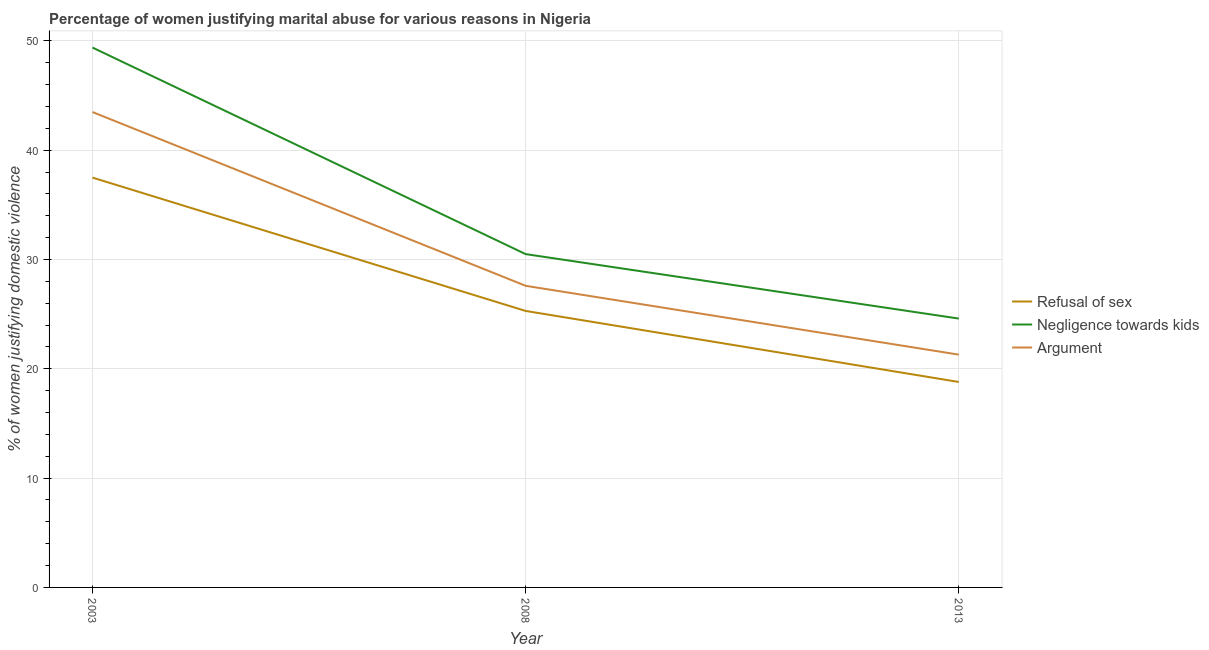Does the line corresponding to percentage of women justifying domestic violence due to negligence towards kids intersect with the line corresponding to percentage of women justifying domestic violence due to refusal of sex?
Your response must be concise. No. What is the percentage of women justifying domestic violence due to negligence towards kids in 2008?
Offer a terse response. 30.5. Across all years, what is the maximum percentage of women justifying domestic violence due to negligence towards kids?
Your answer should be compact. 49.4. Across all years, what is the minimum percentage of women justifying domestic violence due to refusal of sex?
Your response must be concise. 18.8. What is the total percentage of women justifying domestic violence due to negligence towards kids in the graph?
Make the answer very short. 104.5. What is the difference between the percentage of women justifying domestic violence due to arguments in 2013 and the percentage of women justifying domestic violence due to refusal of sex in 2003?
Offer a terse response. -16.2. What is the average percentage of women justifying domestic violence due to arguments per year?
Your response must be concise. 30.8. In the year 2003, what is the difference between the percentage of women justifying domestic violence due to negligence towards kids and percentage of women justifying domestic violence due to refusal of sex?
Your answer should be very brief. 11.9. In how many years, is the percentage of women justifying domestic violence due to arguments greater than 4 %?
Offer a terse response. 3. What is the ratio of the percentage of women justifying domestic violence due to negligence towards kids in 2003 to that in 2008?
Provide a short and direct response. 1.62. Is the difference between the percentage of women justifying domestic violence due to negligence towards kids in 2003 and 2013 greater than the difference between the percentage of women justifying domestic violence due to refusal of sex in 2003 and 2013?
Make the answer very short. Yes. What is the difference between the highest and the lowest percentage of women justifying domestic violence due to negligence towards kids?
Your response must be concise. 24.8. In how many years, is the percentage of women justifying domestic violence due to negligence towards kids greater than the average percentage of women justifying domestic violence due to negligence towards kids taken over all years?
Offer a very short reply. 1. Is the sum of the percentage of women justifying domestic violence due to negligence towards kids in 2003 and 2013 greater than the maximum percentage of women justifying domestic violence due to refusal of sex across all years?
Your answer should be very brief. Yes. Does the percentage of women justifying domestic violence due to refusal of sex monotonically increase over the years?
Ensure brevity in your answer.  No. Is the percentage of women justifying domestic violence due to arguments strictly less than the percentage of women justifying domestic violence due to refusal of sex over the years?
Provide a succinct answer. No. How many lines are there?
Provide a short and direct response. 3. How many years are there in the graph?
Keep it short and to the point. 3. What is the difference between two consecutive major ticks on the Y-axis?
Provide a succinct answer. 10. Does the graph contain grids?
Provide a short and direct response. Yes. How many legend labels are there?
Offer a very short reply. 3. What is the title of the graph?
Offer a terse response. Percentage of women justifying marital abuse for various reasons in Nigeria. Does "Slovak Republic" appear as one of the legend labels in the graph?
Give a very brief answer. No. What is the label or title of the Y-axis?
Give a very brief answer. % of women justifying domestic violence. What is the % of women justifying domestic violence of Refusal of sex in 2003?
Offer a terse response. 37.5. What is the % of women justifying domestic violence in Negligence towards kids in 2003?
Keep it short and to the point. 49.4. What is the % of women justifying domestic violence in Argument in 2003?
Ensure brevity in your answer.  43.5. What is the % of women justifying domestic violence of Refusal of sex in 2008?
Make the answer very short. 25.3. What is the % of women justifying domestic violence in Negligence towards kids in 2008?
Make the answer very short. 30.5. What is the % of women justifying domestic violence in Argument in 2008?
Your answer should be very brief. 27.6. What is the % of women justifying domestic violence in Refusal of sex in 2013?
Make the answer very short. 18.8. What is the % of women justifying domestic violence in Negligence towards kids in 2013?
Provide a succinct answer. 24.6. What is the % of women justifying domestic violence in Argument in 2013?
Make the answer very short. 21.3. Across all years, what is the maximum % of women justifying domestic violence of Refusal of sex?
Provide a short and direct response. 37.5. Across all years, what is the maximum % of women justifying domestic violence in Negligence towards kids?
Provide a succinct answer. 49.4. Across all years, what is the maximum % of women justifying domestic violence in Argument?
Ensure brevity in your answer.  43.5. Across all years, what is the minimum % of women justifying domestic violence of Negligence towards kids?
Keep it short and to the point. 24.6. Across all years, what is the minimum % of women justifying domestic violence in Argument?
Provide a short and direct response. 21.3. What is the total % of women justifying domestic violence of Refusal of sex in the graph?
Offer a very short reply. 81.6. What is the total % of women justifying domestic violence in Negligence towards kids in the graph?
Offer a very short reply. 104.5. What is the total % of women justifying domestic violence of Argument in the graph?
Your answer should be compact. 92.4. What is the difference between the % of women justifying domestic violence of Refusal of sex in 2003 and that in 2008?
Give a very brief answer. 12.2. What is the difference between the % of women justifying domestic violence in Negligence towards kids in 2003 and that in 2008?
Give a very brief answer. 18.9. What is the difference between the % of women justifying domestic violence of Argument in 2003 and that in 2008?
Your response must be concise. 15.9. What is the difference between the % of women justifying domestic violence in Negligence towards kids in 2003 and that in 2013?
Provide a succinct answer. 24.8. What is the difference between the % of women justifying domestic violence of Argument in 2003 and that in 2013?
Offer a very short reply. 22.2. What is the difference between the % of women justifying domestic violence in Refusal of sex in 2008 and that in 2013?
Give a very brief answer. 6.5. What is the difference between the % of women justifying domestic violence of Refusal of sex in 2003 and the % of women justifying domestic violence of Negligence towards kids in 2008?
Provide a short and direct response. 7. What is the difference between the % of women justifying domestic violence of Negligence towards kids in 2003 and the % of women justifying domestic violence of Argument in 2008?
Give a very brief answer. 21.8. What is the difference between the % of women justifying domestic violence in Negligence towards kids in 2003 and the % of women justifying domestic violence in Argument in 2013?
Provide a succinct answer. 28.1. What is the difference between the % of women justifying domestic violence of Refusal of sex in 2008 and the % of women justifying domestic violence of Negligence towards kids in 2013?
Give a very brief answer. 0.7. What is the average % of women justifying domestic violence of Refusal of sex per year?
Provide a short and direct response. 27.2. What is the average % of women justifying domestic violence in Negligence towards kids per year?
Your answer should be compact. 34.83. What is the average % of women justifying domestic violence in Argument per year?
Offer a terse response. 30.8. In the year 2008, what is the difference between the % of women justifying domestic violence in Refusal of sex and % of women justifying domestic violence in Argument?
Your answer should be very brief. -2.3. In the year 2008, what is the difference between the % of women justifying domestic violence of Negligence towards kids and % of women justifying domestic violence of Argument?
Keep it short and to the point. 2.9. In the year 2013, what is the difference between the % of women justifying domestic violence in Refusal of sex and % of women justifying domestic violence in Negligence towards kids?
Your response must be concise. -5.8. In the year 2013, what is the difference between the % of women justifying domestic violence in Refusal of sex and % of women justifying domestic violence in Argument?
Your answer should be compact. -2.5. What is the ratio of the % of women justifying domestic violence of Refusal of sex in 2003 to that in 2008?
Keep it short and to the point. 1.48. What is the ratio of the % of women justifying domestic violence of Negligence towards kids in 2003 to that in 2008?
Ensure brevity in your answer.  1.62. What is the ratio of the % of women justifying domestic violence in Argument in 2003 to that in 2008?
Keep it short and to the point. 1.58. What is the ratio of the % of women justifying domestic violence in Refusal of sex in 2003 to that in 2013?
Ensure brevity in your answer.  1.99. What is the ratio of the % of women justifying domestic violence in Negligence towards kids in 2003 to that in 2013?
Provide a succinct answer. 2.01. What is the ratio of the % of women justifying domestic violence in Argument in 2003 to that in 2013?
Make the answer very short. 2.04. What is the ratio of the % of women justifying domestic violence in Refusal of sex in 2008 to that in 2013?
Ensure brevity in your answer.  1.35. What is the ratio of the % of women justifying domestic violence in Negligence towards kids in 2008 to that in 2013?
Give a very brief answer. 1.24. What is the ratio of the % of women justifying domestic violence in Argument in 2008 to that in 2013?
Your answer should be compact. 1.3. What is the difference between the highest and the second highest % of women justifying domestic violence of Argument?
Give a very brief answer. 15.9. What is the difference between the highest and the lowest % of women justifying domestic violence of Refusal of sex?
Provide a succinct answer. 18.7. What is the difference between the highest and the lowest % of women justifying domestic violence of Negligence towards kids?
Provide a short and direct response. 24.8. What is the difference between the highest and the lowest % of women justifying domestic violence of Argument?
Ensure brevity in your answer.  22.2. 